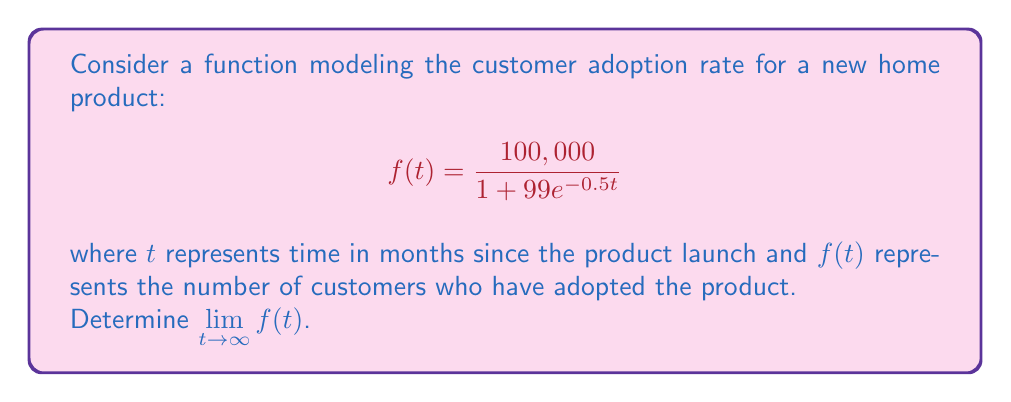Show me your answer to this math problem. To find the limit of this function as $t$ approaches infinity, we'll follow these steps:

1) First, let's examine the structure of the function:
   $$f(t) = \frac{100,000}{1 + 99e^{-0.5t}}$$

2) As $t$ approaches infinity, $e^{-0.5t}$ approaches 0 because the exponent becomes a large negative number.

3) Therefore, as $t \to \infty$:
   $$\lim_{t \to \infty} f(t) = \lim_{t \to \infty} \frac{100,000}{1 + 99e^{-0.5t}}$$

4) Substituting the limit of $e^{-0.5t}$:
   $$= \frac{100,000}{1 + 99 \cdot 0} = \frac{100,000}{1} = 100,000$$

5) This result makes sense in the context of the problem. The function models a logistic growth curve, where 100,000 represents the maximum number of customers that can adopt the product (the market saturation point).
Answer: $\lim_{t \to \infty} f(t) = 100,000$ 